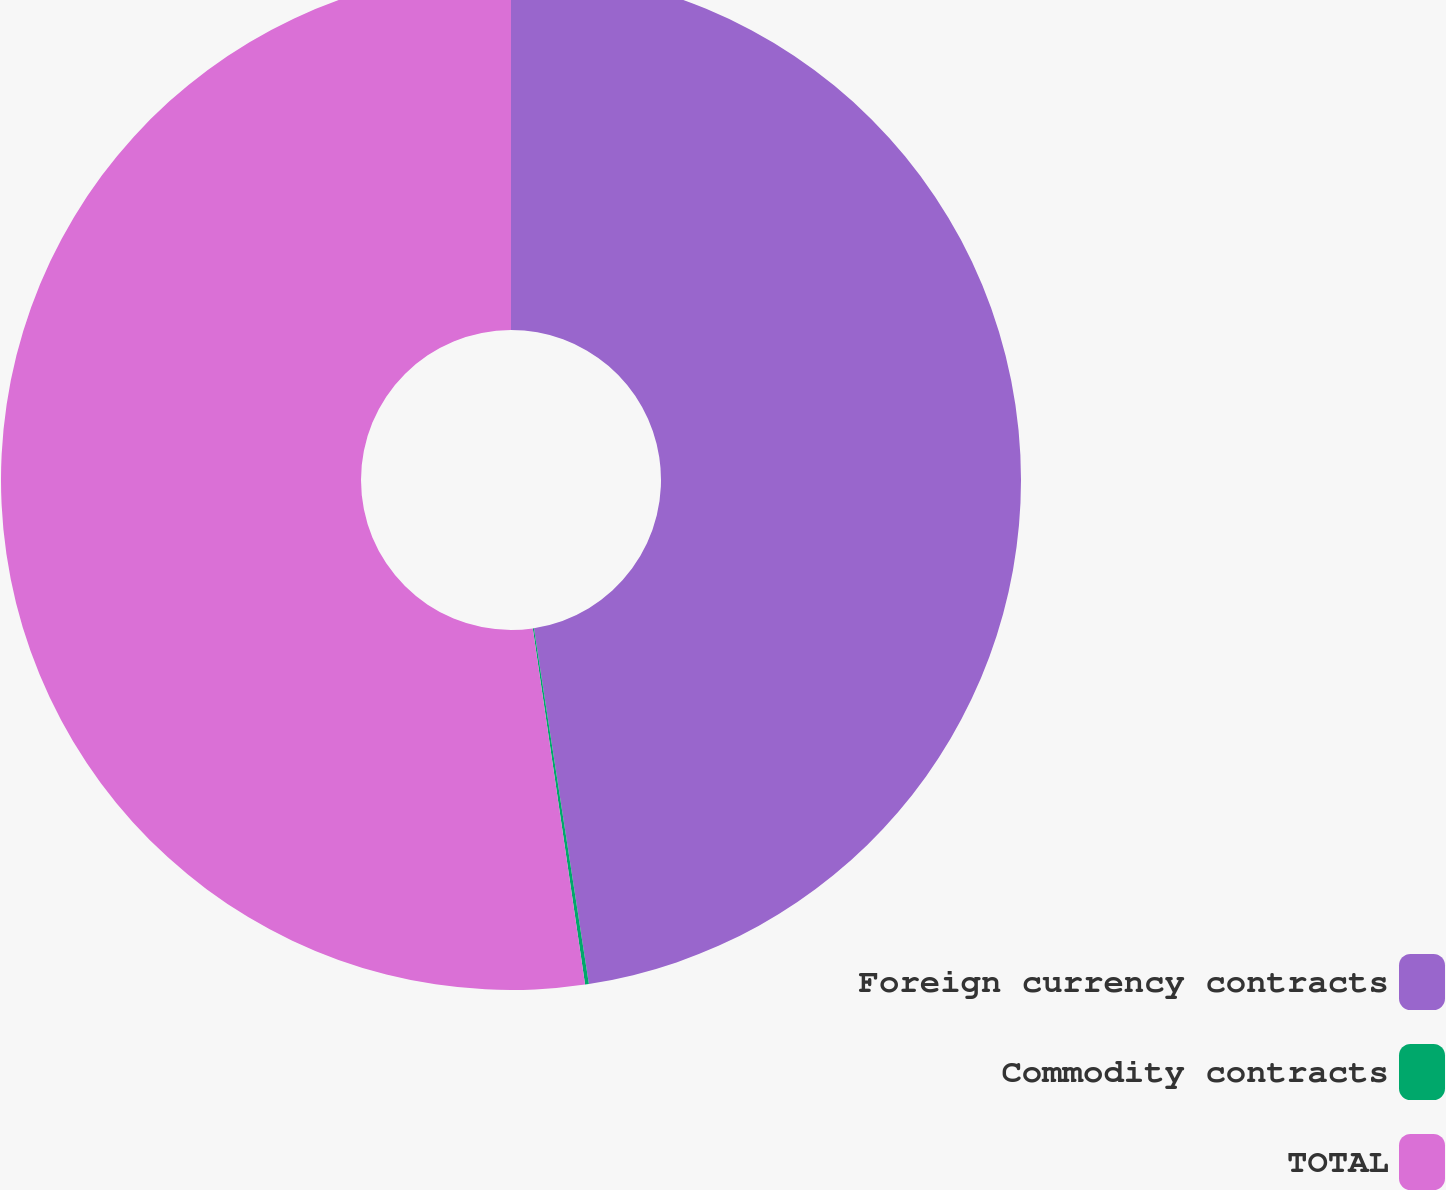Convert chart. <chart><loc_0><loc_0><loc_500><loc_500><pie_chart><fcel>Foreign currency contracts<fcel>Commodity contracts<fcel>TOTAL<nl><fcel>47.56%<fcel>0.12%<fcel>52.32%<nl></chart> 